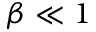Convert formula to latex. <formula><loc_0><loc_0><loc_500><loc_500>\beta \ll 1</formula> 